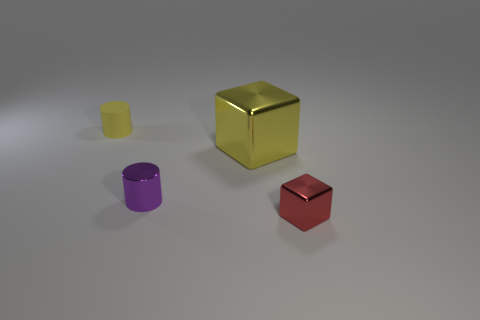Add 4 small metal spheres. How many objects exist? 8 Add 1 large yellow matte cylinders. How many large yellow matte cylinders exist? 1 Subtract 0 purple blocks. How many objects are left? 4 Subtract all big gray matte things. Subtract all yellow shiny blocks. How many objects are left? 3 Add 1 small purple things. How many small purple things are left? 2 